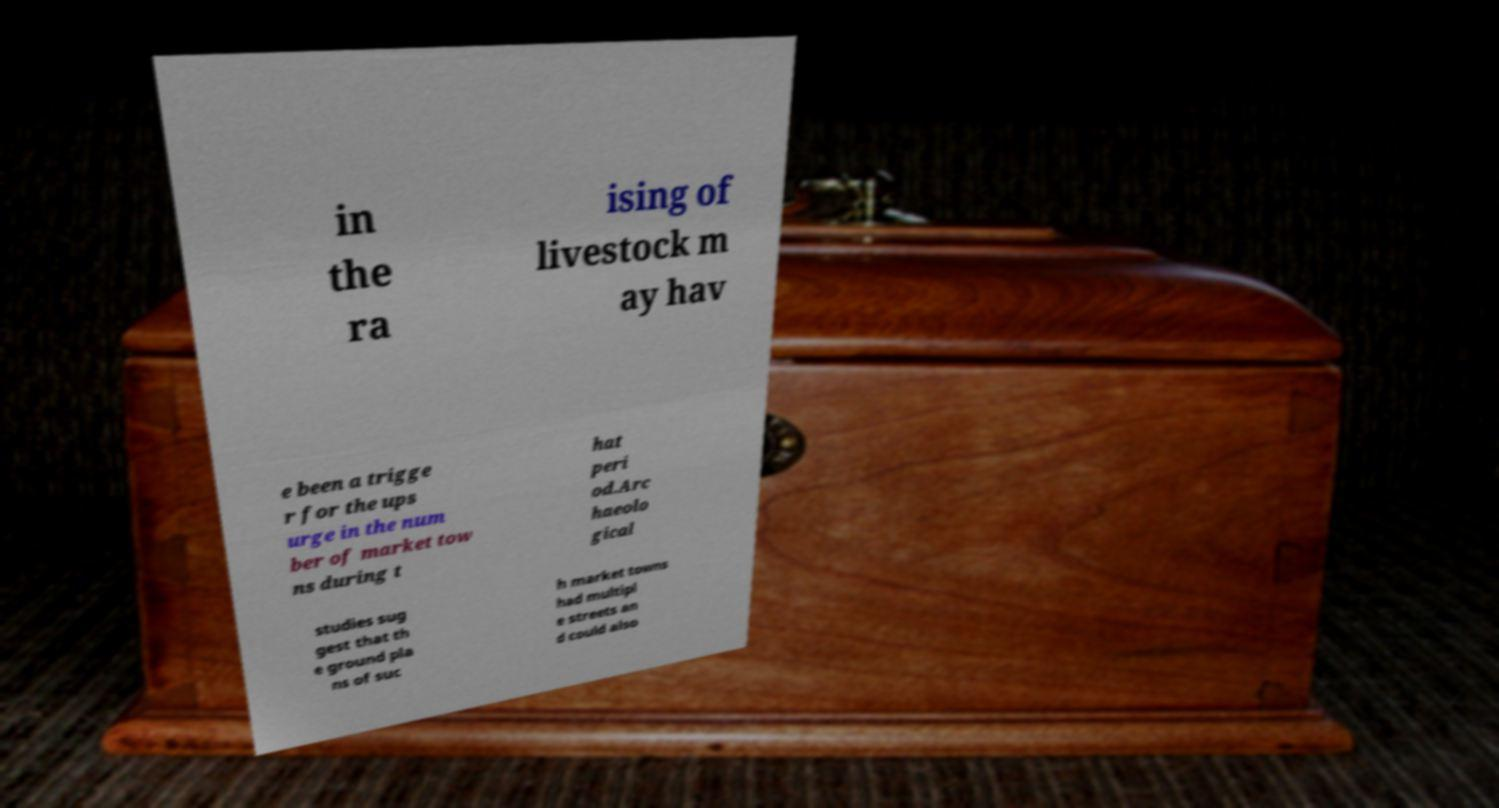Please identify and transcribe the text found in this image. in the ra ising of livestock m ay hav e been a trigge r for the ups urge in the num ber of market tow ns during t hat peri od.Arc haeolo gical studies sug gest that th e ground pla ns of suc h market towns had multipl e streets an d could also 